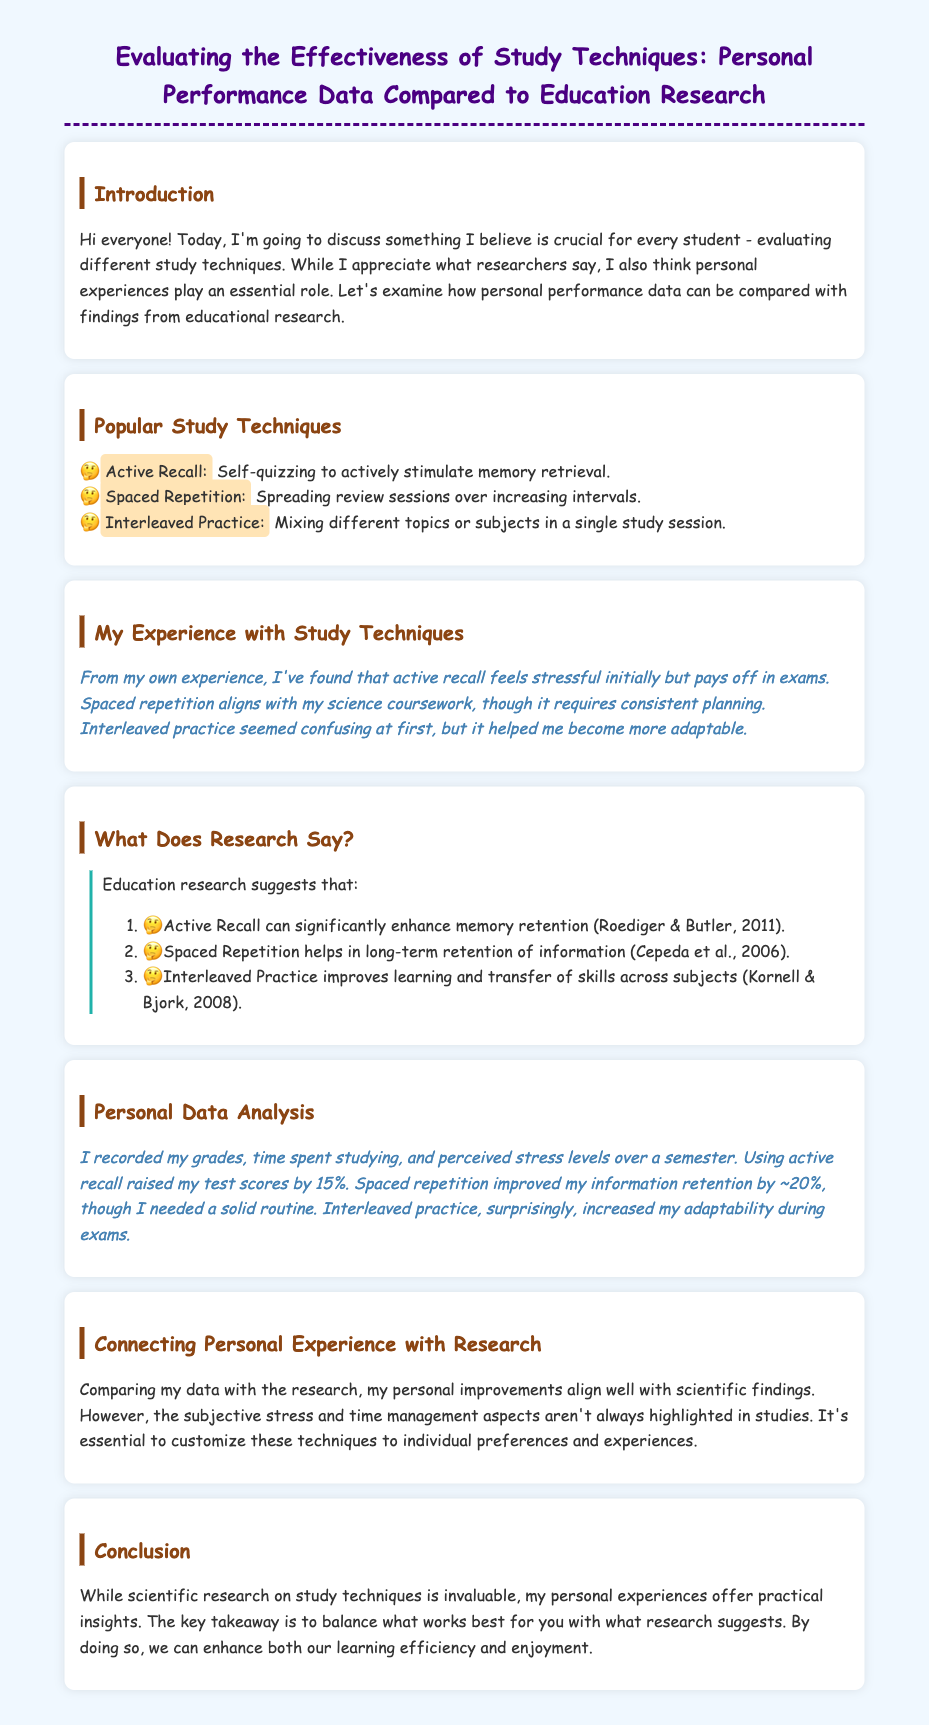What is the title of the document? The title of the document is presented at the top of the rendered page.
Answer: Evaluating the Effectiveness of Study Techniques: Personal Performance Data Compared to Education Research What is one popular study technique mentioned? The document lists several study techniques under the "Popular Study Techniques" section.
Answer: Active Recall What percentage did test scores increase using active recall? The personal data analysis section states the improvement in test scores due to active recall.
Answer: 15% What research paper year is associated with spaced repetition effectiveness? The research cited in the document includes several papers with publication years.
Answer: 2006 How does interleaved practice affect adaptability according to personal experience? The document mentions the effect of interleaved practice on adaptability in the "Personal Data Analysis" section.
Answer: Increased adaptability What does the document suggest is essential for study techniques? The conclusion emphasizes the importance of balancing personal experiences with research.
Answer: Customization What type of experience does the author prioritize in their analysis? The author discusses a specific emphasis on their own experiences throughout the document.
Answer: Personal experiences 